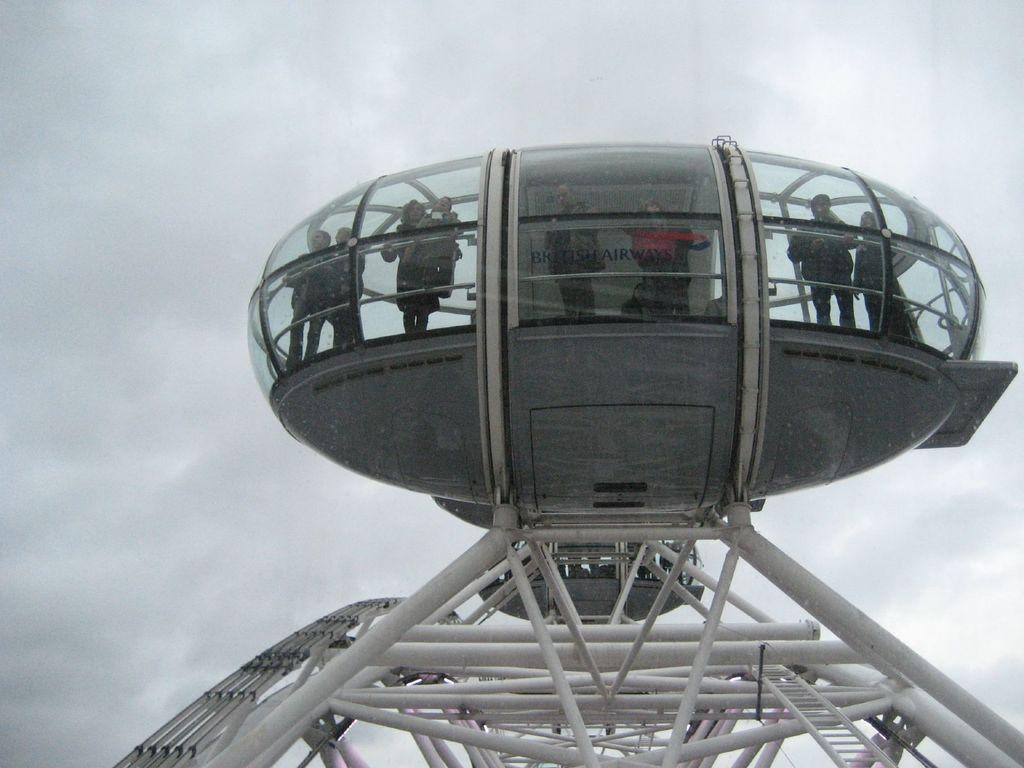What is the main subject of the image? The main subject of the image is a device that resembles a space machine. What can be seen inside the device? There are people standing inside the device. What can be seen in the background of the image? The sky is visible in the background of the image. What type of riddle can be seen written on the side of the device? There is no riddle written on the side of the device in the image. Can you tell me how many hydrants are visible in the image? There are no hydrants present in the image. 